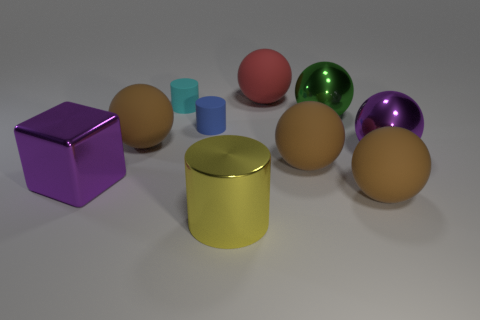Subtract all gray cylinders. How many brown balls are left? 3 Subtract all large purple metal spheres. How many spheres are left? 5 Subtract all purple spheres. How many spheres are left? 5 Subtract all yellow spheres. Subtract all blue cylinders. How many spheres are left? 6 Subtract all cylinders. How many objects are left? 7 Add 7 small blue cylinders. How many small blue cylinders are left? 8 Add 2 large blue cylinders. How many large blue cylinders exist? 2 Subtract 0 purple cylinders. How many objects are left? 10 Subtract all rubber balls. Subtract all balls. How many objects are left? 0 